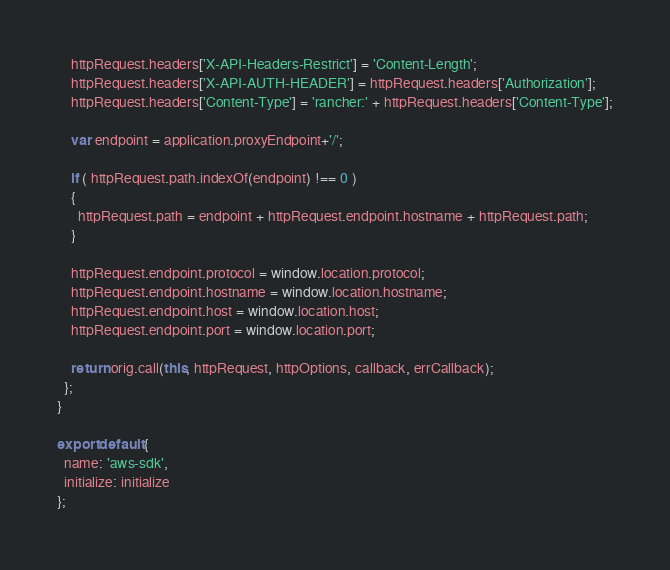<code> <loc_0><loc_0><loc_500><loc_500><_JavaScript_>    httpRequest.headers['X-API-Headers-Restrict'] = 'Content-Length';
    httpRequest.headers['X-API-AUTH-HEADER'] = httpRequest.headers['Authorization'];
    httpRequest.headers['Content-Type'] = 'rancher:' + httpRequest.headers['Content-Type'];

    var endpoint = application.proxyEndpoint+'/';

    if ( httpRequest.path.indexOf(endpoint) !== 0 )
    {
      httpRequest.path = endpoint + httpRequest.endpoint.hostname + httpRequest.path;
    }

    httpRequest.endpoint.protocol = window.location.protocol;
    httpRequest.endpoint.hostname = window.location.hostname;
    httpRequest.endpoint.host = window.location.host;
    httpRequest.endpoint.port = window.location.port;

    return orig.call(this, httpRequest, httpOptions, callback, errCallback);
  };
}

export default {
  name: 'aws-sdk',
  initialize: initialize
};
</code> 